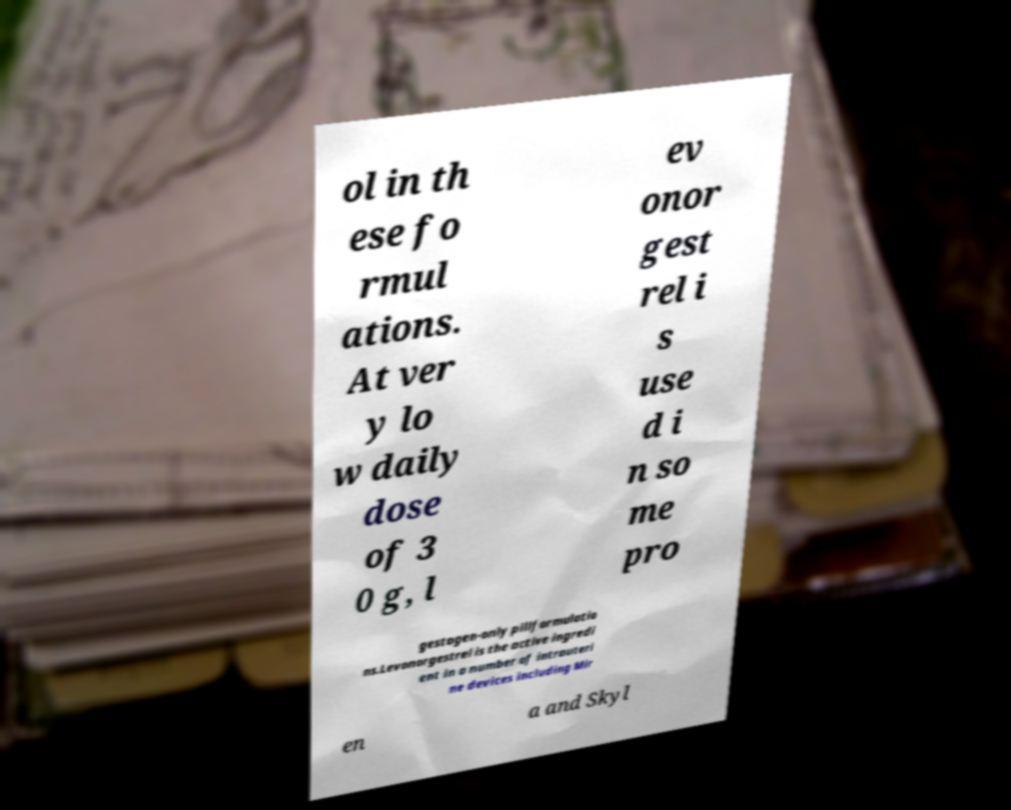Can you accurately transcribe the text from the provided image for me? ol in th ese fo rmul ations. At ver y lo w daily dose of 3 0 g, l ev onor gest rel i s use d i n so me pro gestogen-only pillformulatio ns.Levonorgestrel is the active ingredi ent in a number of intrauteri ne devices including Mir en a and Skyl 